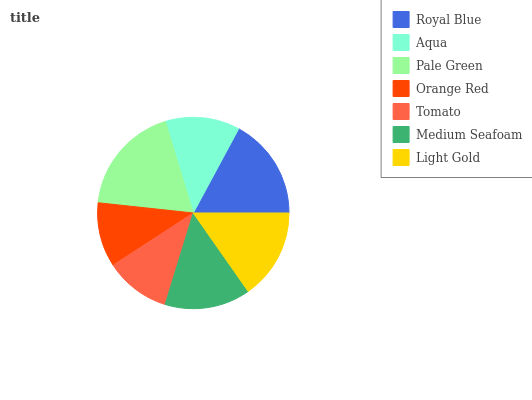Is Orange Red the minimum?
Answer yes or no. Yes. Is Pale Green the maximum?
Answer yes or no. Yes. Is Aqua the minimum?
Answer yes or no. No. Is Aqua the maximum?
Answer yes or no. No. Is Royal Blue greater than Aqua?
Answer yes or no. Yes. Is Aqua less than Royal Blue?
Answer yes or no. Yes. Is Aqua greater than Royal Blue?
Answer yes or no. No. Is Royal Blue less than Aqua?
Answer yes or no. No. Is Medium Seafoam the high median?
Answer yes or no. Yes. Is Medium Seafoam the low median?
Answer yes or no. Yes. Is Pale Green the high median?
Answer yes or no. No. Is Orange Red the low median?
Answer yes or no. No. 